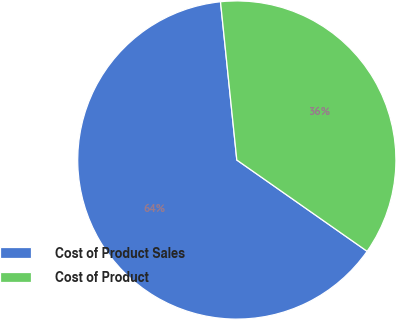Convert chart to OTSL. <chart><loc_0><loc_0><loc_500><loc_500><pie_chart><fcel>Cost of Product Sales<fcel>Cost of Product<nl><fcel>63.64%<fcel>36.36%<nl></chart> 